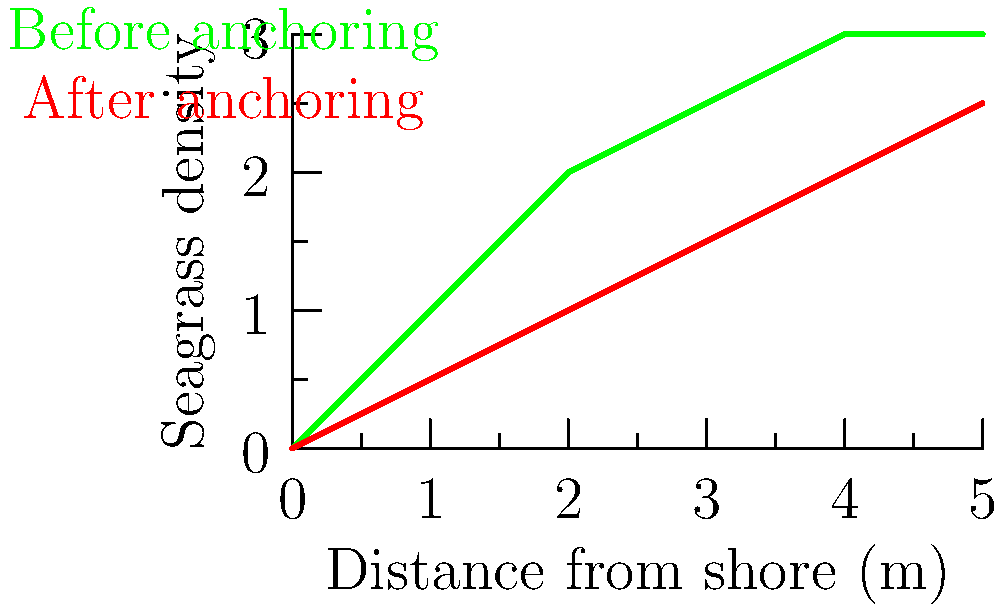Based on the before-and-after diagram showing seagrass density in relation to distance from shore, estimate the percentage reduction in overall seagrass density due to yacht anchoring. Assume the area under each curve represents total seagrass density. To estimate the percentage reduction in overall seagrass density:

1. Approximate the area under each curve:
   - Before anchoring: Roughly a trapezoid with base 5m and heights 0 and 3
     Area ≈ $\frac{1}{2}(0+3) \times 5 = 7.5$ units
   - After anchoring: Roughly a triangle with base 5m and height 2.5
     Area ≈ $\frac{1}{2} \times 5 \times 2.5 = 6.25$ units

2. Calculate the difference in areas:
   $7.5 - 6.25 = 1.25$ units

3. Calculate the percentage reduction:
   Percentage reduction = $\frac{\text{Difference}}{\text{Original}} \times 100\%$
   $= \frac{1.25}{7.5} \times 100\% \approx 16.67\%$

4. Round to the nearest 5% for a reasonable estimate:
   $16.67\% \approx 15\%$
Answer: Approximately 15% 